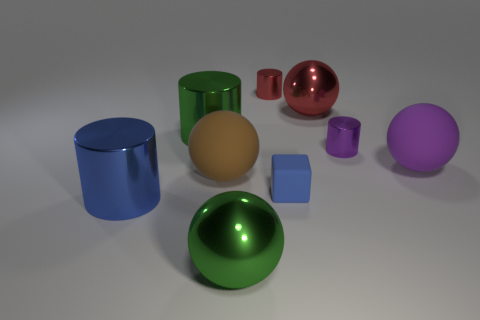Subtract 1 balls. How many balls are left? 3 Add 1 large blue objects. How many objects exist? 10 Subtract all spheres. How many objects are left? 5 Add 6 brown matte objects. How many brown matte objects are left? 7 Add 2 purple things. How many purple things exist? 4 Subtract 0 cyan cylinders. How many objects are left? 9 Subtract all blue metallic things. Subtract all shiny cylinders. How many objects are left? 4 